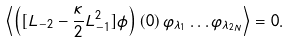<formula> <loc_0><loc_0><loc_500><loc_500>\left < \left ( [ L _ { - 2 } - \frac { \kappa } { 2 } L _ { - 1 } ^ { 2 } ] \phi \right ) ( 0 ) \, \varphi _ { \lambda _ { 1 } } \dots \varphi _ { \lambda _ { 2 N } } \right > = 0 .</formula> 